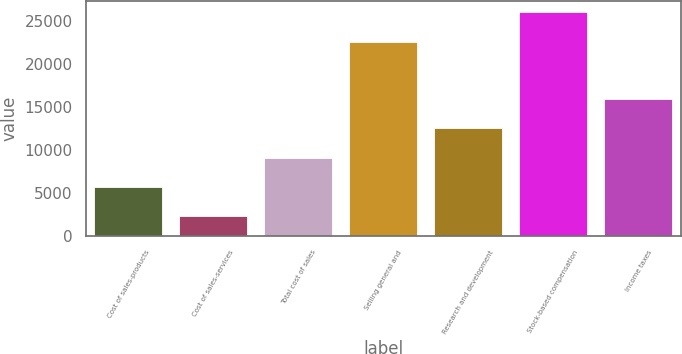Convert chart. <chart><loc_0><loc_0><loc_500><loc_500><bar_chart><fcel>Cost of sales-products<fcel>Cost of sales-services<fcel>Total cost of sales<fcel>Selling general and<fcel>Research and development<fcel>Stock-based compensation<fcel>Income taxes<nl><fcel>5677.6<fcel>2276<fcel>9079.2<fcel>22560<fcel>12480.8<fcel>25961.6<fcel>15882.4<nl></chart> 